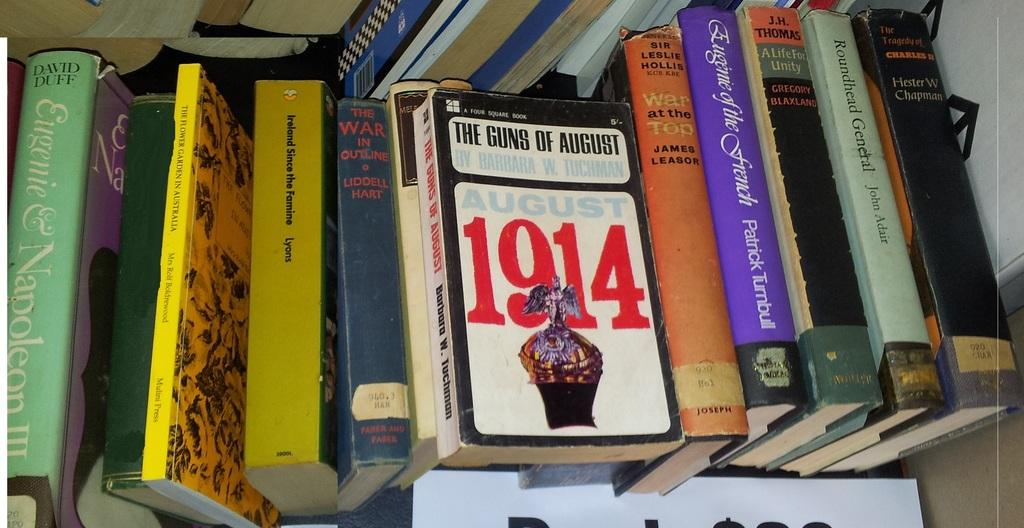<image>
Render a clear and concise summary of the photo. White book that says August 1914 on top of other books. 